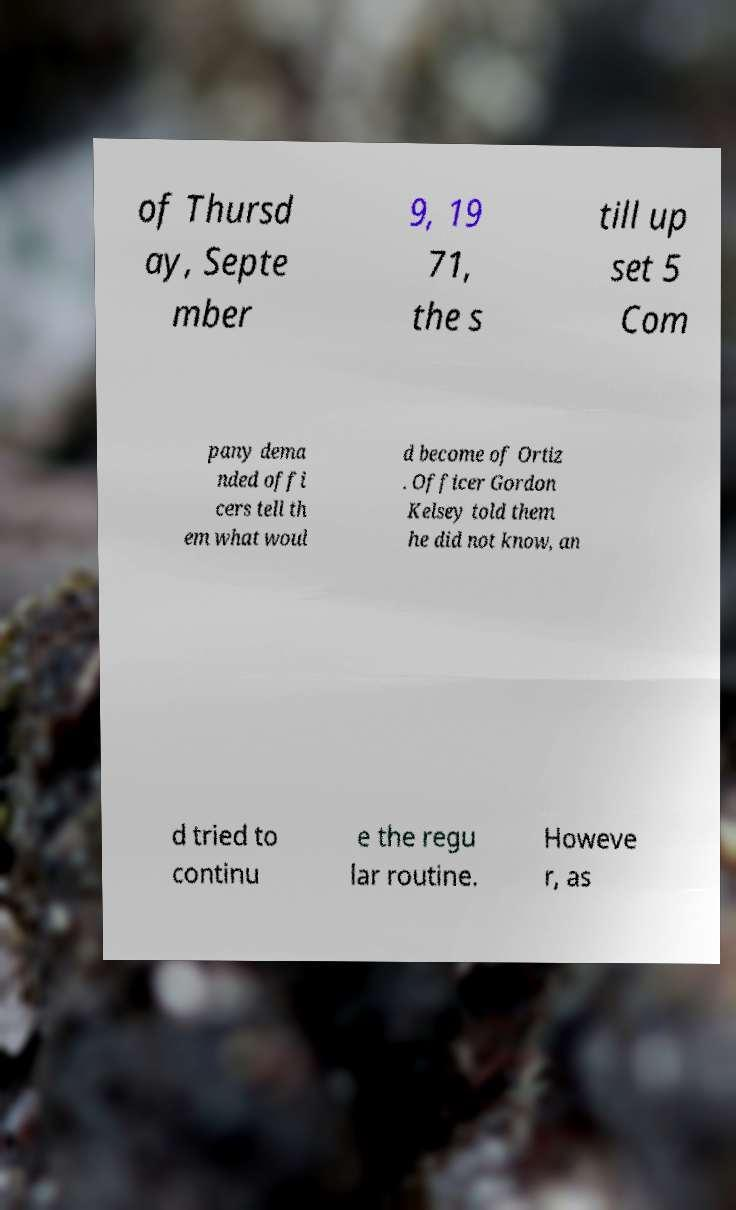For documentation purposes, I need the text within this image transcribed. Could you provide that? of Thursd ay, Septe mber 9, 19 71, the s till up set 5 Com pany dema nded offi cers tell th em what woul d become of Ortiz . Officer Gordon Kelsey told them he did not know, an d tried to continu e the regu lar routine. Howeve r, as 